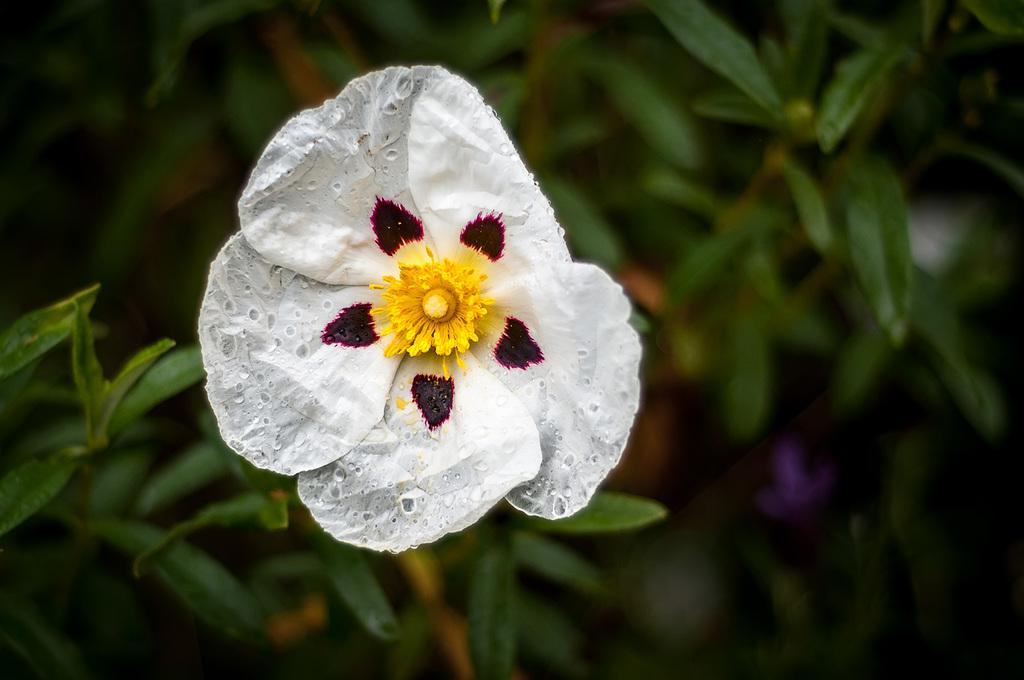What is the main subject in the center of the image? There is a flower in the center of the image. What else can be seen at the bottom of the image? There are plants at the bottom of the image. How many people are fighting in the image? There are no people present in the image, so there is no fighting taking place. Can you describe the sun's position in the image? The provided facts do not mention the sun, so we cannot describe its position in the image. 